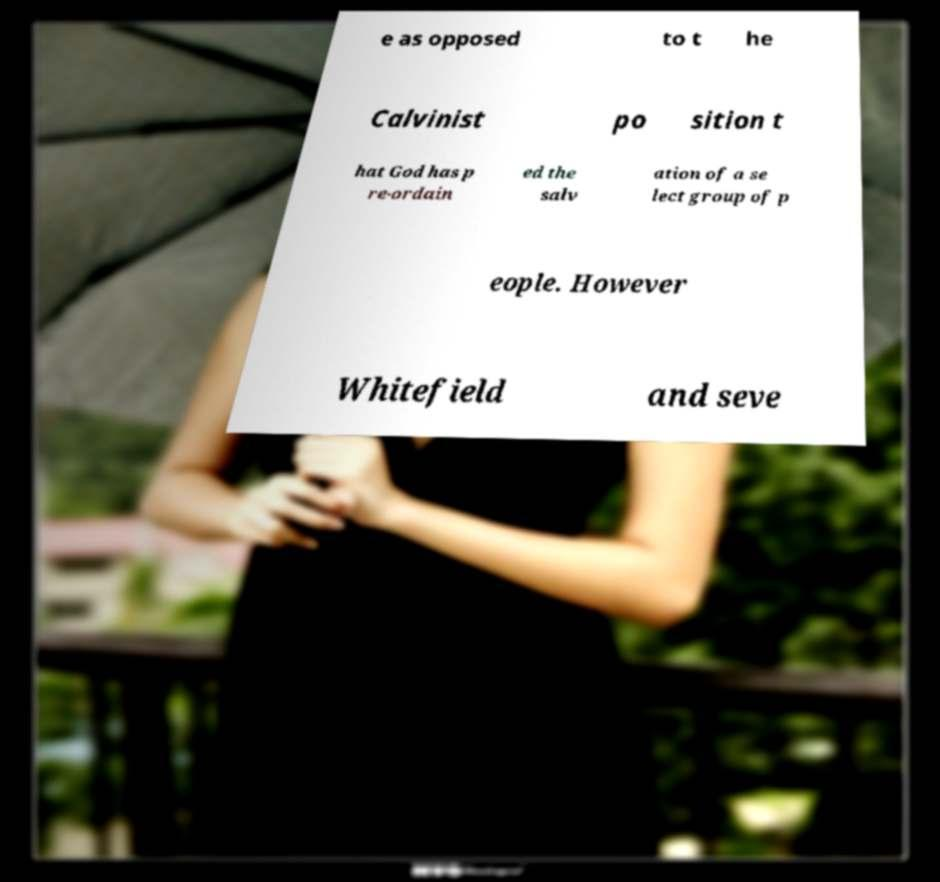Could you extract and type out the text from this image? e as opposed to t he Calvinist po sition t hat God has p re-ordain ed the salv ation of a se lect group of p eople. However Whitefield and seve 